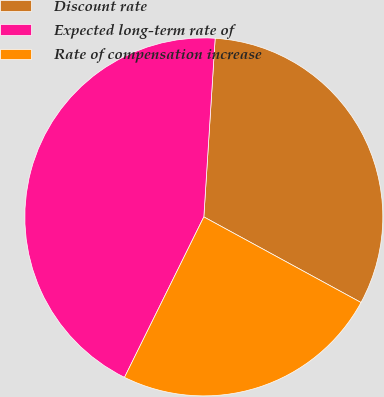Convert chart. <chart><loc_0><loc_0><loc_500><loc_500><pie_chart><fcel>Discount rate<fcel>Expected long-term rate of<fcel>Rate of compensation increase<nl><fcel>31.93%<fcel>43.7%<fcel>24.37%<nl></chart> 